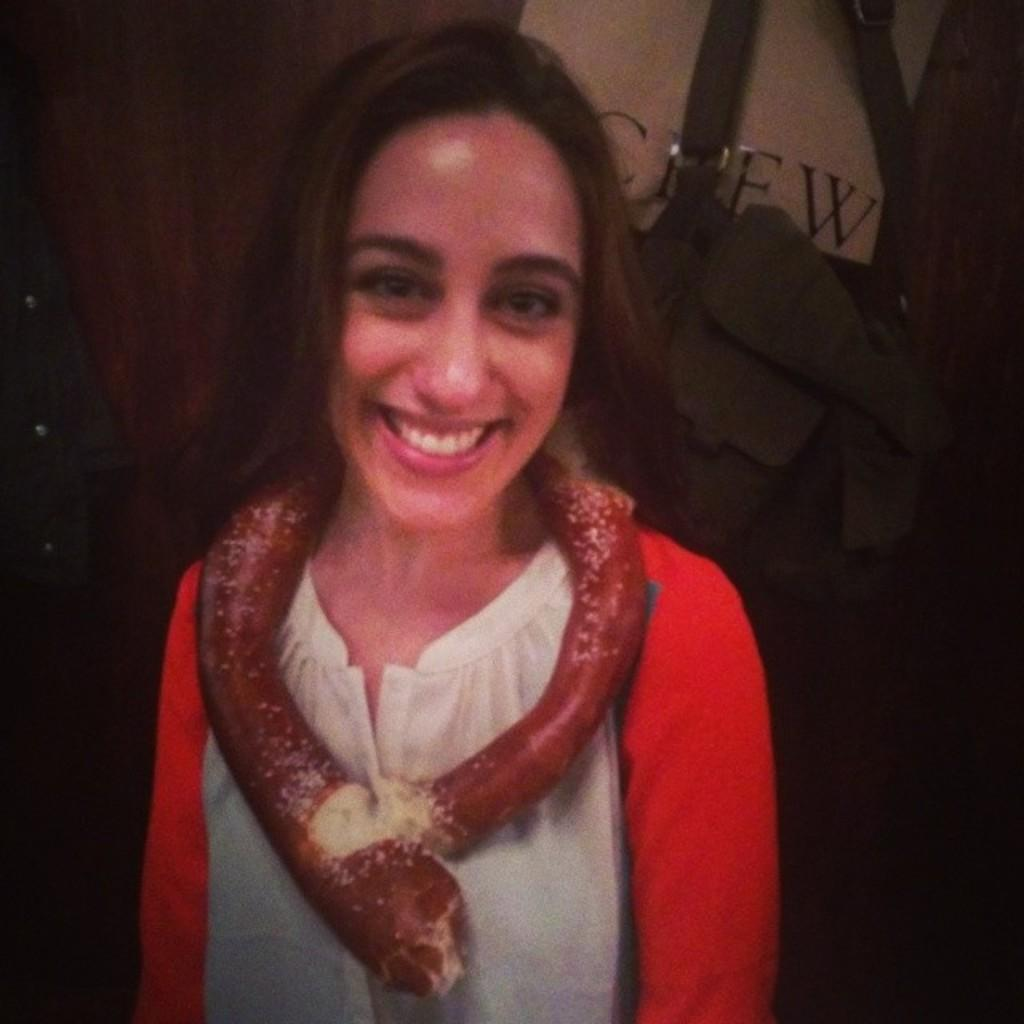What is the main subject of the image? There is a lady standing in the center of the image. What can be seen in the background of the image? There is a wall and clothes placed on a hanger in the background of the image. What type of sail can be seen in the image? There is no sail present in the image. What material is the brass used for in the image? There is no brass present in the image. 